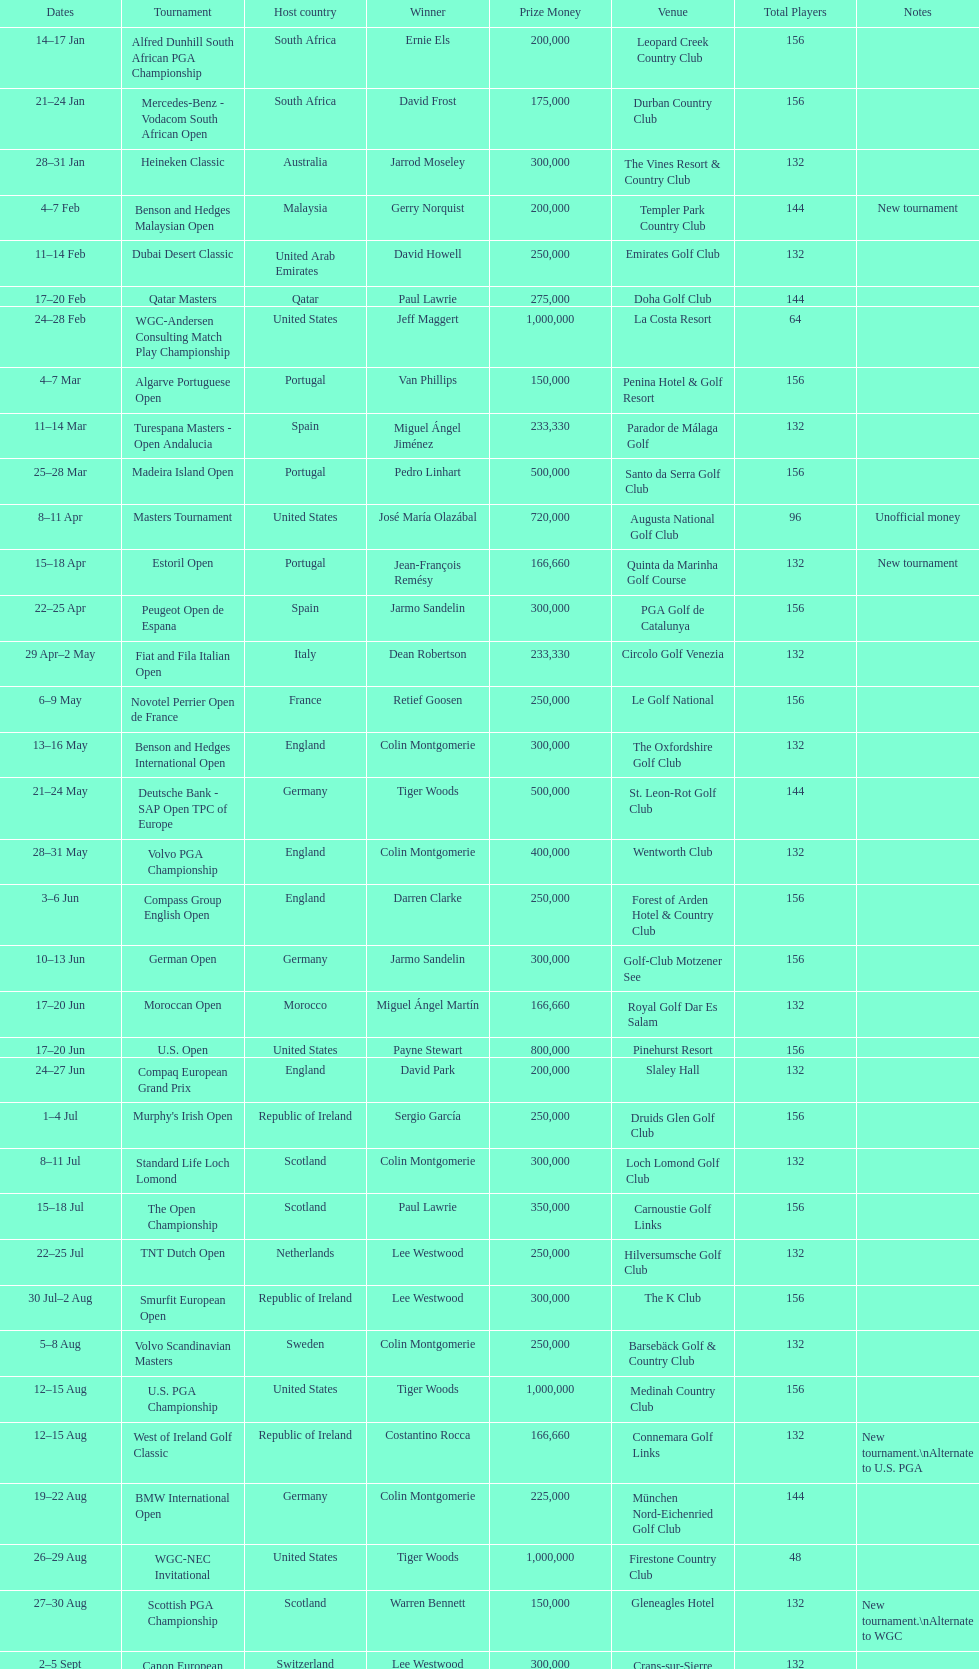Which winner won more tournaments, jeff maggert or tiger woods? Tiger Woods. 